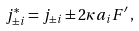Convert formula to latex. <formula><loc_0><loc_0><loc_500><loc_500>j ^ { * } _ { \pm i } = j _ { \pm i } \pm 2 \kappa a _ { i } F ^ { \prime } \, ,</formula> 